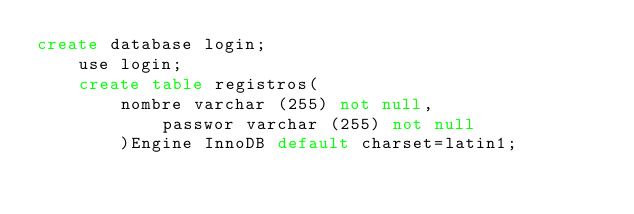Convert code to text. <code><loc_0><loc_0><loc_500><loc_500><_SQL_>create database login;
	use login;
	create table registros(
		nombre varchar (255) not null,
			passwor varchar (255) not null
		)Engine InnoDB default charset=latin1;</code> 